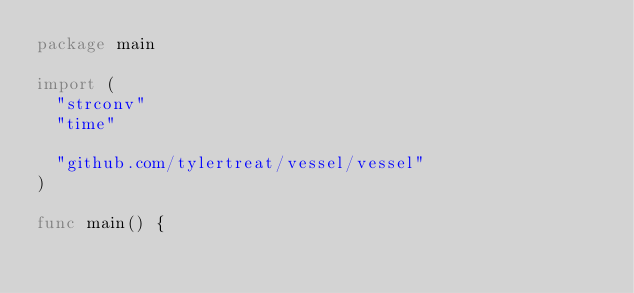<code> <loc_0><loc_0><loc_500><loc_500><_Go_>package main

import (
	"strconv"
	"time"

	"github.com/tylertreat/vessel/vessel"
)

func main() {</code> 